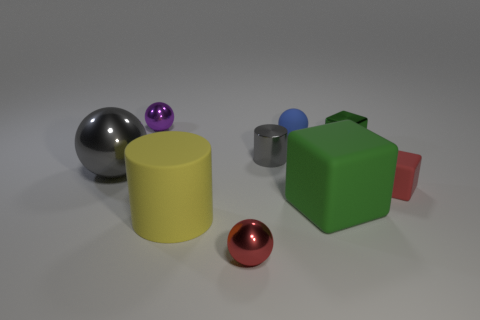Subtract all spheres. How many objects are left? 5 Subtract all small purple shiny things. Subtract all large gray matte things. How many objects are left? 8 Add 2 green rubber things. How many green rubber things are left? 3 Add 5 big yellow matte cylinders. How many big yellow matte cylinders exist? 6 Subtract 0 brown spheres. How many objects are left? 9 